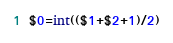<code> <loc_0><loc_0><loc_500><loc_500><_Awk_>$0=int(($1+$2+1)/2)</code> 